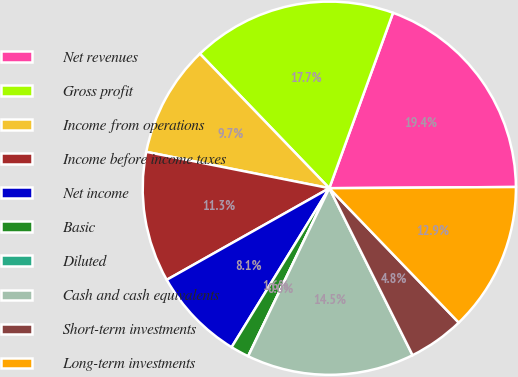Convert chart to OTSL. <chart><loc_0><loc_0><loc_500><loc_500><pie_chart><fcel>Net revenues<fcel>Gross profit<fcel>Income from operations<fcel>Income before income taxes<fcel>Net income<fcel>Basic<fcel>Diluted<fcel>Cash and cash equivalents<fcel>Short-term investments<fcel>Long-term investments<nl><fcel>19.35%<fcel>17.74%<fcel>9.68%<fcel>11.29%<fcel>8.06%<fcel>1.61%<fcel>0.0%<fcel>14.52%<fcel>4.84%<fcel>12.9%<nl></chart> 